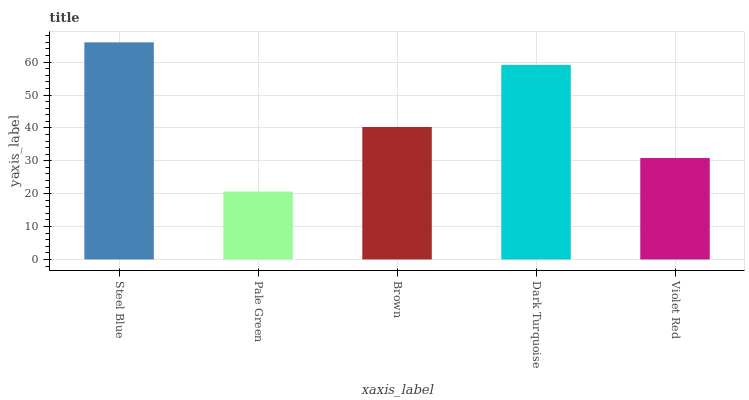Is Pale Green the minimum?
Answer yes or no. Yes. Is Steel Blue the maximum?
Answer yes or no. Yes. Is Brown the minimum?
Answer yes or no. No. Is Brown the maximum?
Answer yes or no. No. Is Brown greater than Pale Green?
Answer yes or no. Yes. Is Pale Green less than Brown?
Answer yes or no. Yes. Is Pale Green greater than Brown?
Answer yes or no. No. Is Brown less than Pale Green?
Answer yes or no. No. Is Brown the high median?
Answer yes or no. Yes. Is Brown the low median?
Answer yes or no. Yes. Is Violet Red the high median?
Answer yes or no. No. Is Dark Turquoise the low median?
Answer yes or no. No. 